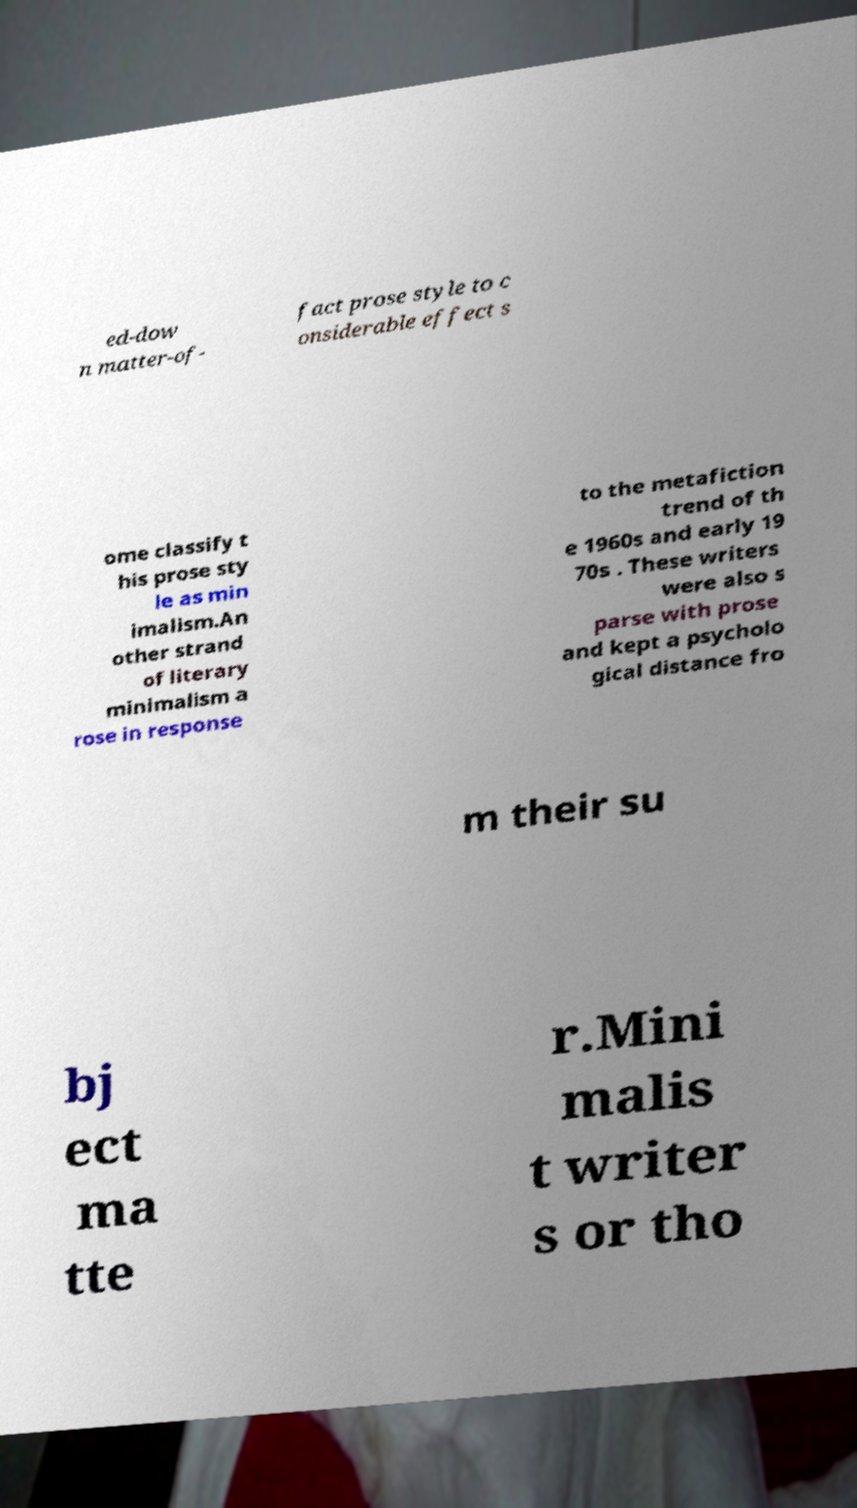Please read and relay the text visible in this image. What does it say? ed-dow n matter-of- fact prose style to c onsiderable effect s ome classify t his prose sty le as min imalism.An other strand of literary minimalism a rose in response to the metafiction trend of th e 1960s and early 19 70s . These writers were also s parse with prose and kept a psycholo gical distance fro m their su bj ect ma tte r.Mini malis t writer s or tho 